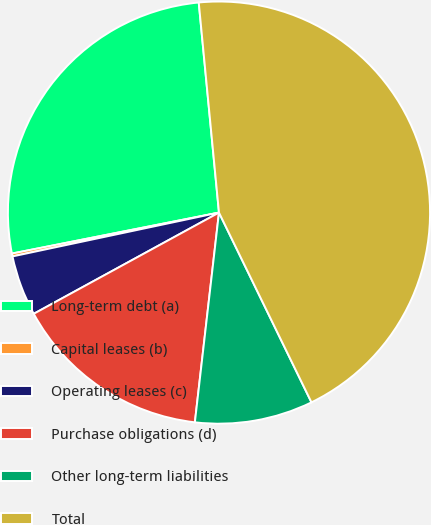Convert chart. <chart><loc_0><loc_0><loc_500><loc_500><pie_chart><fcel>Long-term debt (a)<fcel>Capital leases (b)<fcel>Operating leases (c)<fcel>Purchase obligations (d)<fcel>Other long-term liabilities<fcel>Total<nl><fcel>26.58%<fcel>0.22%<fcel>4.63%<fcel>15.22%<fcel>9.04%<fcel>44.31%<nl></chart> 